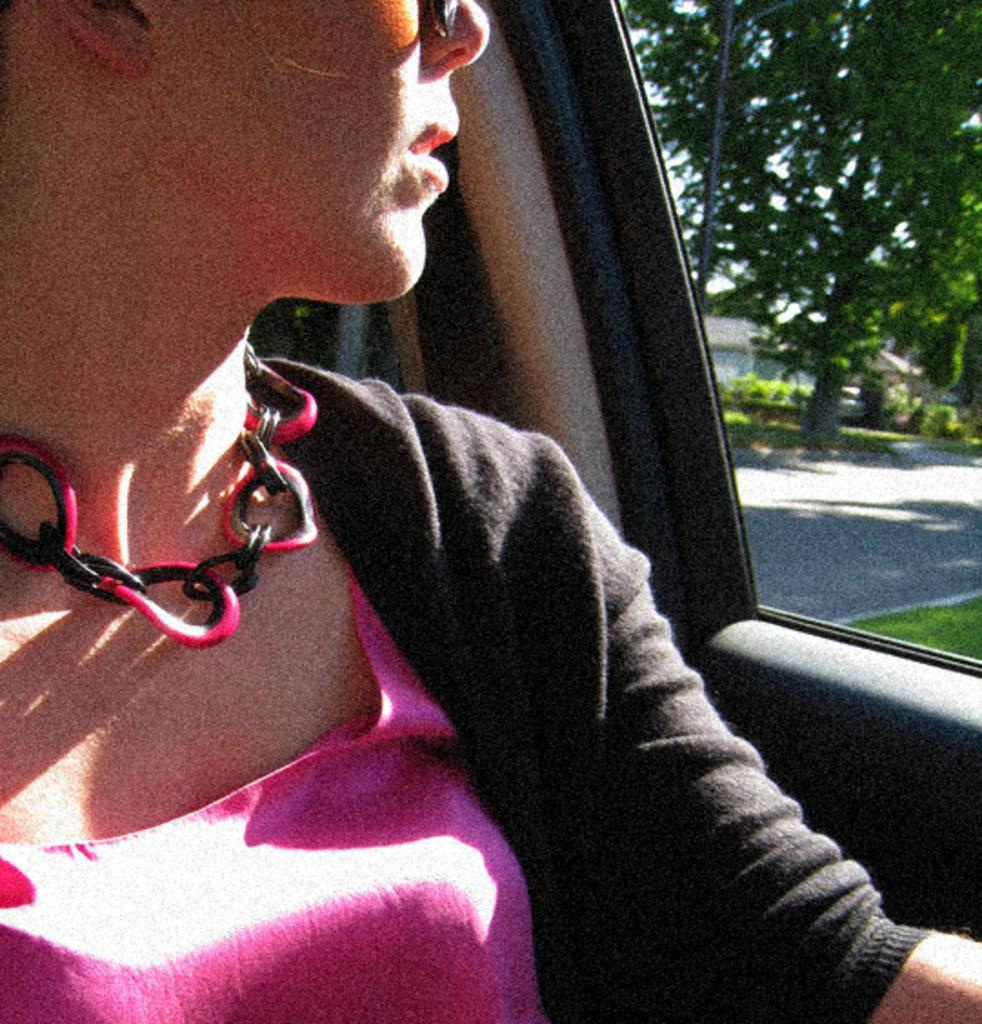Who is in the car in the image? There is a woman in the car in the image. What can be seen in the background of the image? There are trees, houses, and a road in the background of the image. What type of light can be seen coming from the fireman's helmet in the image? There is no fireman or light coming from a helmet present in the image. What type of bushes can be seen in the image? There is no mention of bushes in the provided facts, so we cannot determine if they are present in the image. 